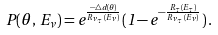<formula> <loc_0><loc_0><loc_500><loc_500>P ( \theta , \, E _ { \nu } ) = e ^ { \frac { - \bigtriangleup d { ( \theta ) } } { R _ { \nu _ { \tau } } ( E _ { \nu } ) } } ( 1 - e ^ { - \frac { R _ { \tau } ( E _ { \tau } ) } { R _ { \nu _ { \tau } } ( E _ { \nu } ) } } ) \, .</formula> 